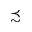<formula> <loc_0><loc_0><loc_500><loc_500>\prec s i m</formula> 